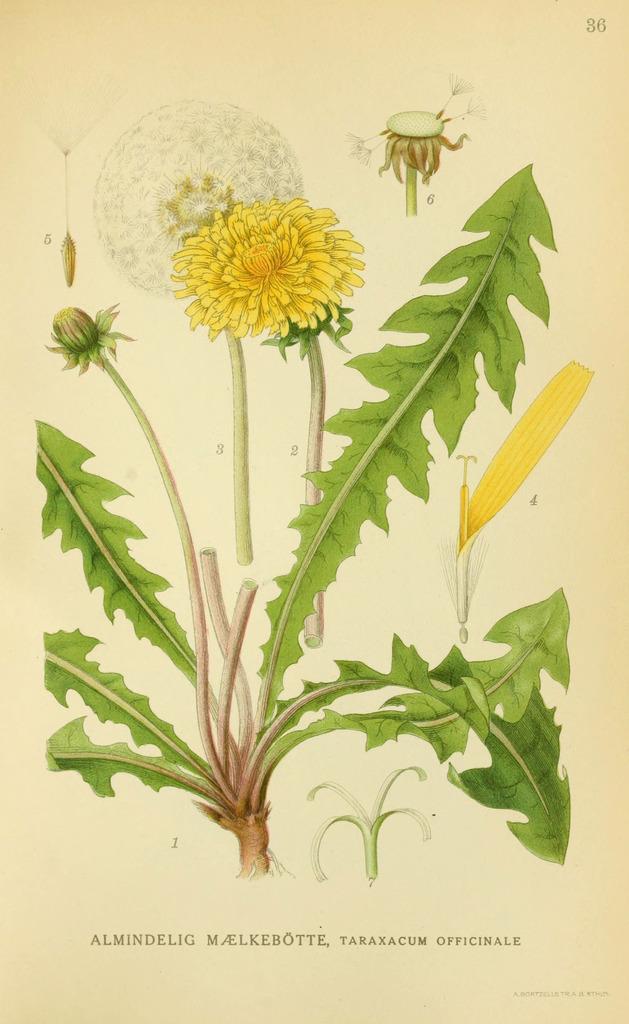How would you summarize this image in a sentence or two? In this image we can see a poster, there is a plant, there is an yellow flower, there is a bud. 